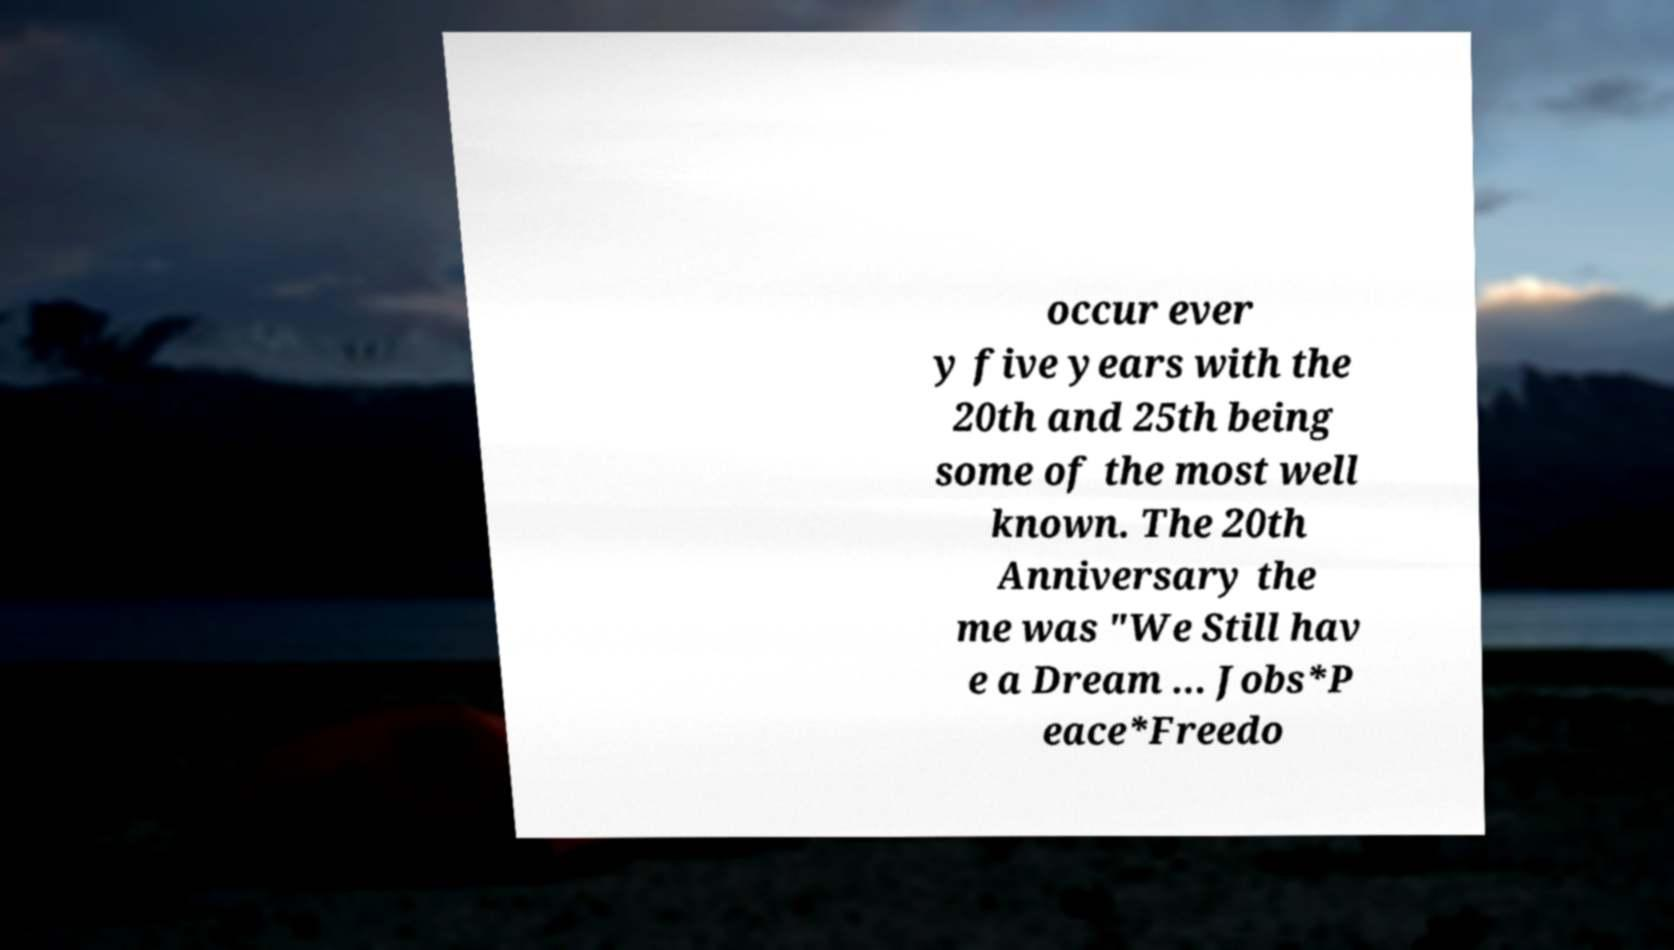Could you assist in decoding the text presented in this image and type it out clearly? occur ever y five years with the 20th and 25th being some of the most well known. The 20th Anniversary the me was "We Still hav e a Dream ... Jobs*P eace*Freedo 